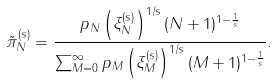<formula> <loc_0><loc_0><loc_500><loc_500>\tilde { \pi } _ { N } ^ { ( s ) } = \frac { p _ { N } \left ( \xi _ { N } ^ { ( s ) } \right ) ^ { 1 / s } ( N + 1 ) ^ { 1 - \frac { 1 } { s } } } { \sum _ { M = 0 } ^ { \infty } p _ { M } \left ( \xi _ { M } ^ { ( s ) } \right ) ^ { 1 / s } ( M + 1 ) ^ { 1 - \frac { 1 } { s } } } .</formula> 